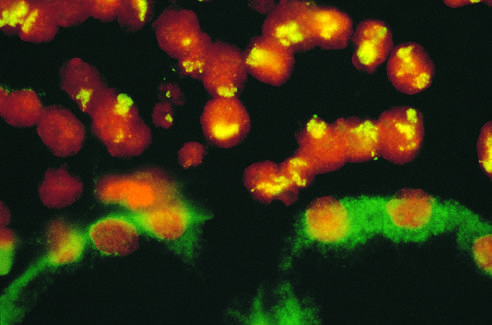what do renal tubular epithelial cells in the lower half of the photograph show?
Answer the question using a single word or phrase. No nuclear staining and background (green) cytoplasmic staining 